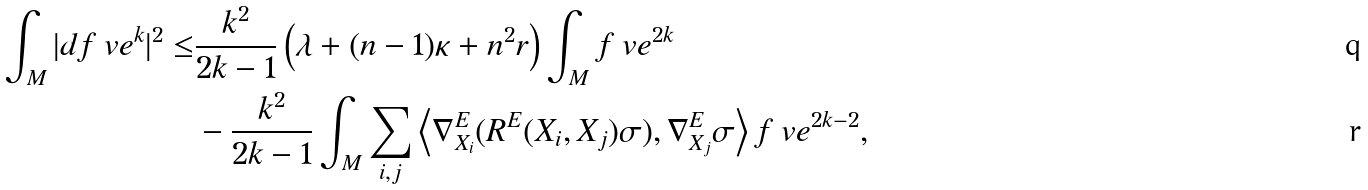Convert formula to latex. <formula><loc_0><loc_0><loc_500><loc_500>\int _ { M } | d f _ { \ } v e ^ { k } | ^ { 2 } \leq & \frac { k ^ { 2 } } { 2 k - 1 } \left ( \lambda + ( n - 1 ) \kappa + n ^ { 2 } r \right ) \int _ { M } f _ { \ } v e ^ { 2 k } \\ & - \frac { k ^ { 2 } } { 2 k - 1 } \int _ { M } \sum _ { i , j } \left \langle \nabla ^ { E } _ { X _ { i } } ( R ^ { E } ( X _ { i } , X _ { j } ) \sigma ) , \nabla ^ { E } _ { X _ { j } } \sigma \right \rangle f _ { \ } v e ^ { 2 k - 2 } ,</formula> 